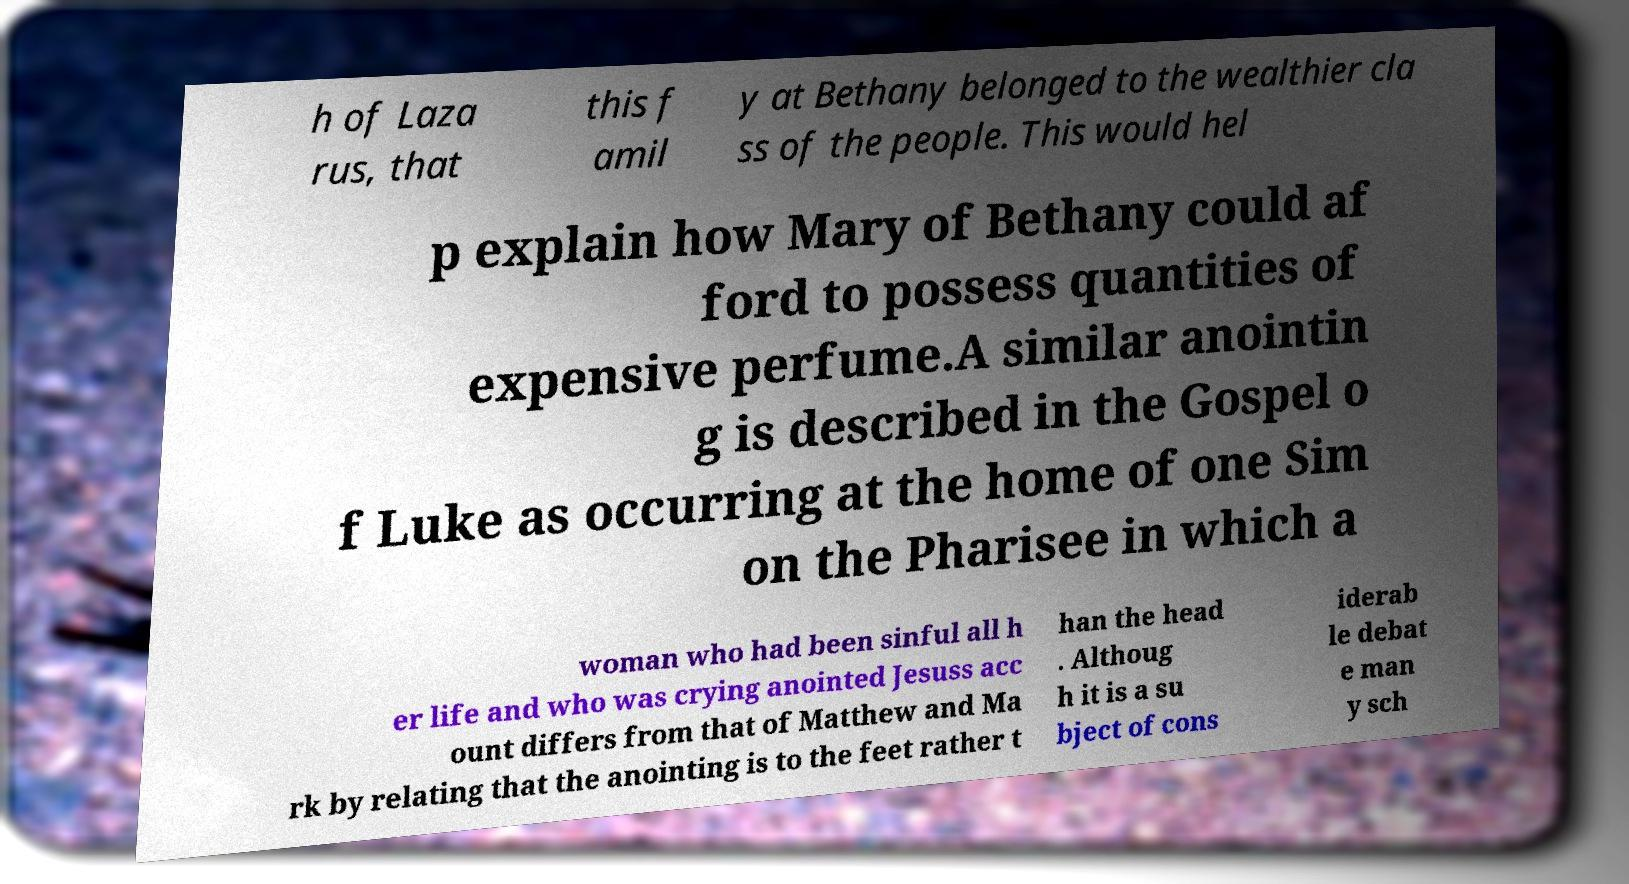Can you accurately transcribe the text from the provided image for me? h of Laza rus, that this f amil y at Bethany belonged to the wealthier cla ss of the people. This would hel p explain how Mary of Bethany could af ford to possess quantities of expensive perfume.A similar anointin g is described in the Gospel o f Luke as occurring at the home of one Sim on the Pharisee in which a woman who had been sinful all h er life and who was crying anointed Jesuss acc ount differs from that of Matthew and Ma rk by relating that the anointing is to the feet rather t han the head . Althoug h it is a su bject of cons iderab le debat e man y sch 